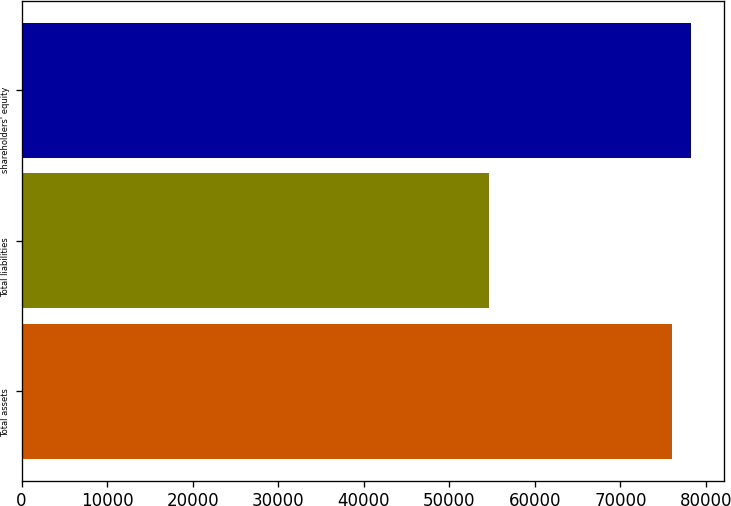<chart> <loc_0><loc_0><loc_500><loc_500><bar_chart><fcel>Total assets<fcel>Total liabilities<fcel>shareholders' equity<nl><fcel>76079<fcel>54590<fcel>78227.9<nl></chart> 